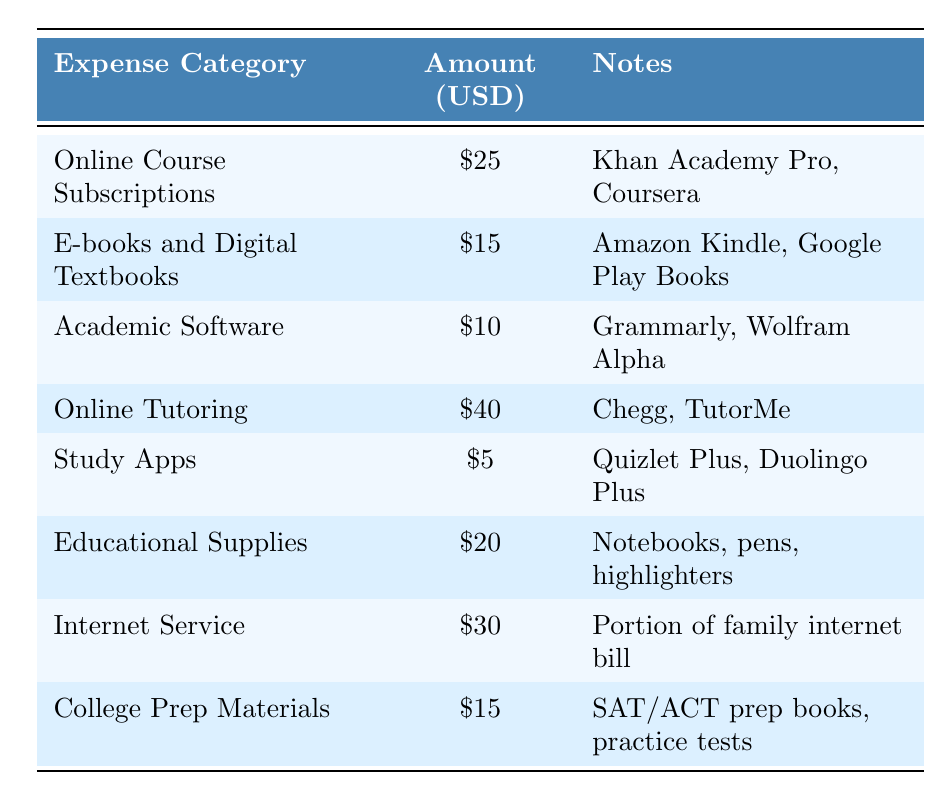What is the total amount allocated for Online Course Subscriptions? The table shows that the amount for Online Course Subscriptions is $25.
Answer: $25 How much does a student spend on E-books and Digital Textbooks? The table lists the amount for E-books and Digital Textbooks as $15.
Answer: $15 What is the total spending on Academic Software and Online Tutoring combined? Academic Software costs $10 and Online Tutoring costs $40. Adding them gives $10 + $40 = $50.
Answer: $50 Are Study Apps the least expensive category in the budget? The table shows that Study Apps cost $5, which is less than all other categories listed.
Answer: Yes What is the total monthly spending on Educational Supplies and College Prep Materials? Educational Supplies cost $20 and College Prep Materials cost $15. The total is $20 + $15 = $35.
Answer: $35 Is the amount spent on Internet Service higher than that of E-books and Digital Textbooks? Internet Service costs $30, while E-books and Digital Textbooks costs $15. Since $30 is greater than $15, the answer is yes.
Answer: Yes What is the average expenditure across all categories listed in the budget? The total amount can be calculated by adding all categories: $25 + $15 + $10 + $40 + $5 + $20 + $30 + $15 = $150. There are 8 categories, so the average is $150 / 8 = $18.75.
Answer: $18.75 What is the difference between the highest and lowest expense categories? The highest expense is Online Tutoring at $40, and the lowest is Study Apps at $5. The difference is $40 - $5 = $35.
Answer: $35 How much more is spent on Online Tutoring than on Academic Software? Online Tutoring costs $40 and Academic Software costs $10. The difference is $40 - $10 = $30.
Answer: $30 Is the total for Internet Service and Educational Supplies less than $60? Internet Service costs $30 and Educational Supplies costs $20. Their total is $30 + $20 = $50, which is less than $60.
Answer: Yes 